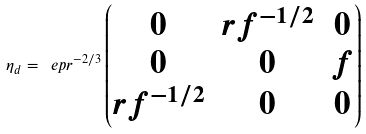Convert formula to latex. <formula><loc_0><loc_0><loc_500><loc_500>\eta _ { d } = \ e p r ^ { - 2 / 3 } \begin{pmatrix} 0 & r f ^ { - 1 / 2 } & 0 \\ 0 & 0 & f \\ r f ^ { - 1 / 2 } & 0 & 0 \end{pmatrix}</formula> 